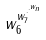Convert formula to latex. <formula><loc_0><loc_0><loc_500><loc_500>w _ { 6 } ^ { w _ { 7 } ^ { \cdot ^ { \cdot ^ { w _ { n } } } } }</formula> 